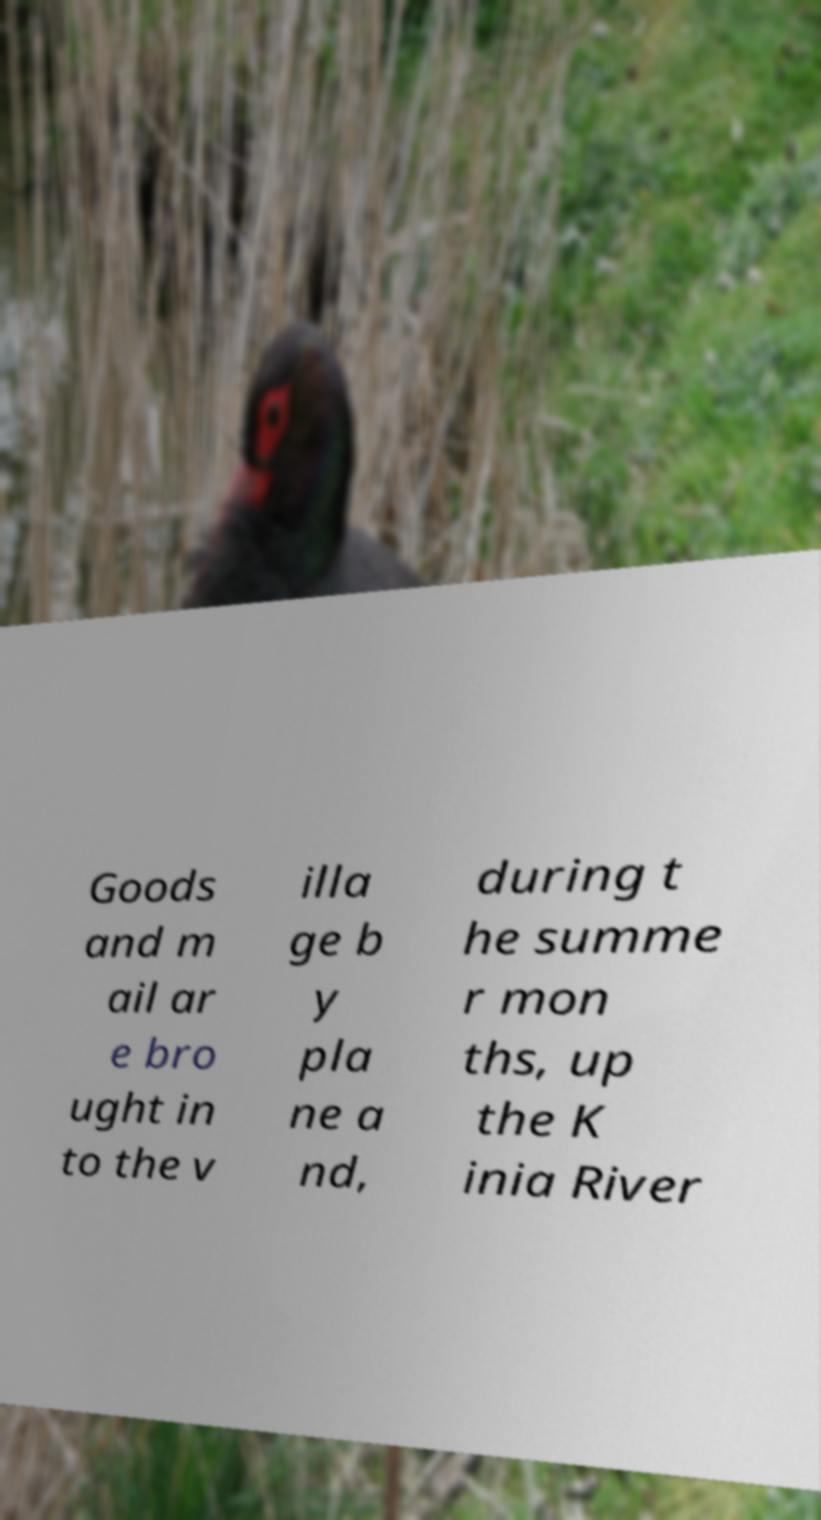Can you accurately transcribe the text from the provided image for me? Goods and m ail ar e bro ught in to the v illa ge b y pla ne a nd, during t he summe r mon ths, up the K inia River 